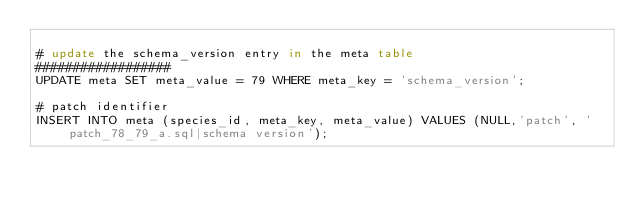Convert code to text. <code><loc_0><loc_0><loc_500><loc_500><_SQL_>
# update the schema_version entry in the meta table
##################
UPDATE meta SET meta_value = 79 WHERE meta_key = 'schema_version';

# patch identifier
INSERT INTO meta (species_id, meta_key, meta_value) VALUES (NULL,'patch', 'patch_78_79_a.sql|schema version');
</code> 